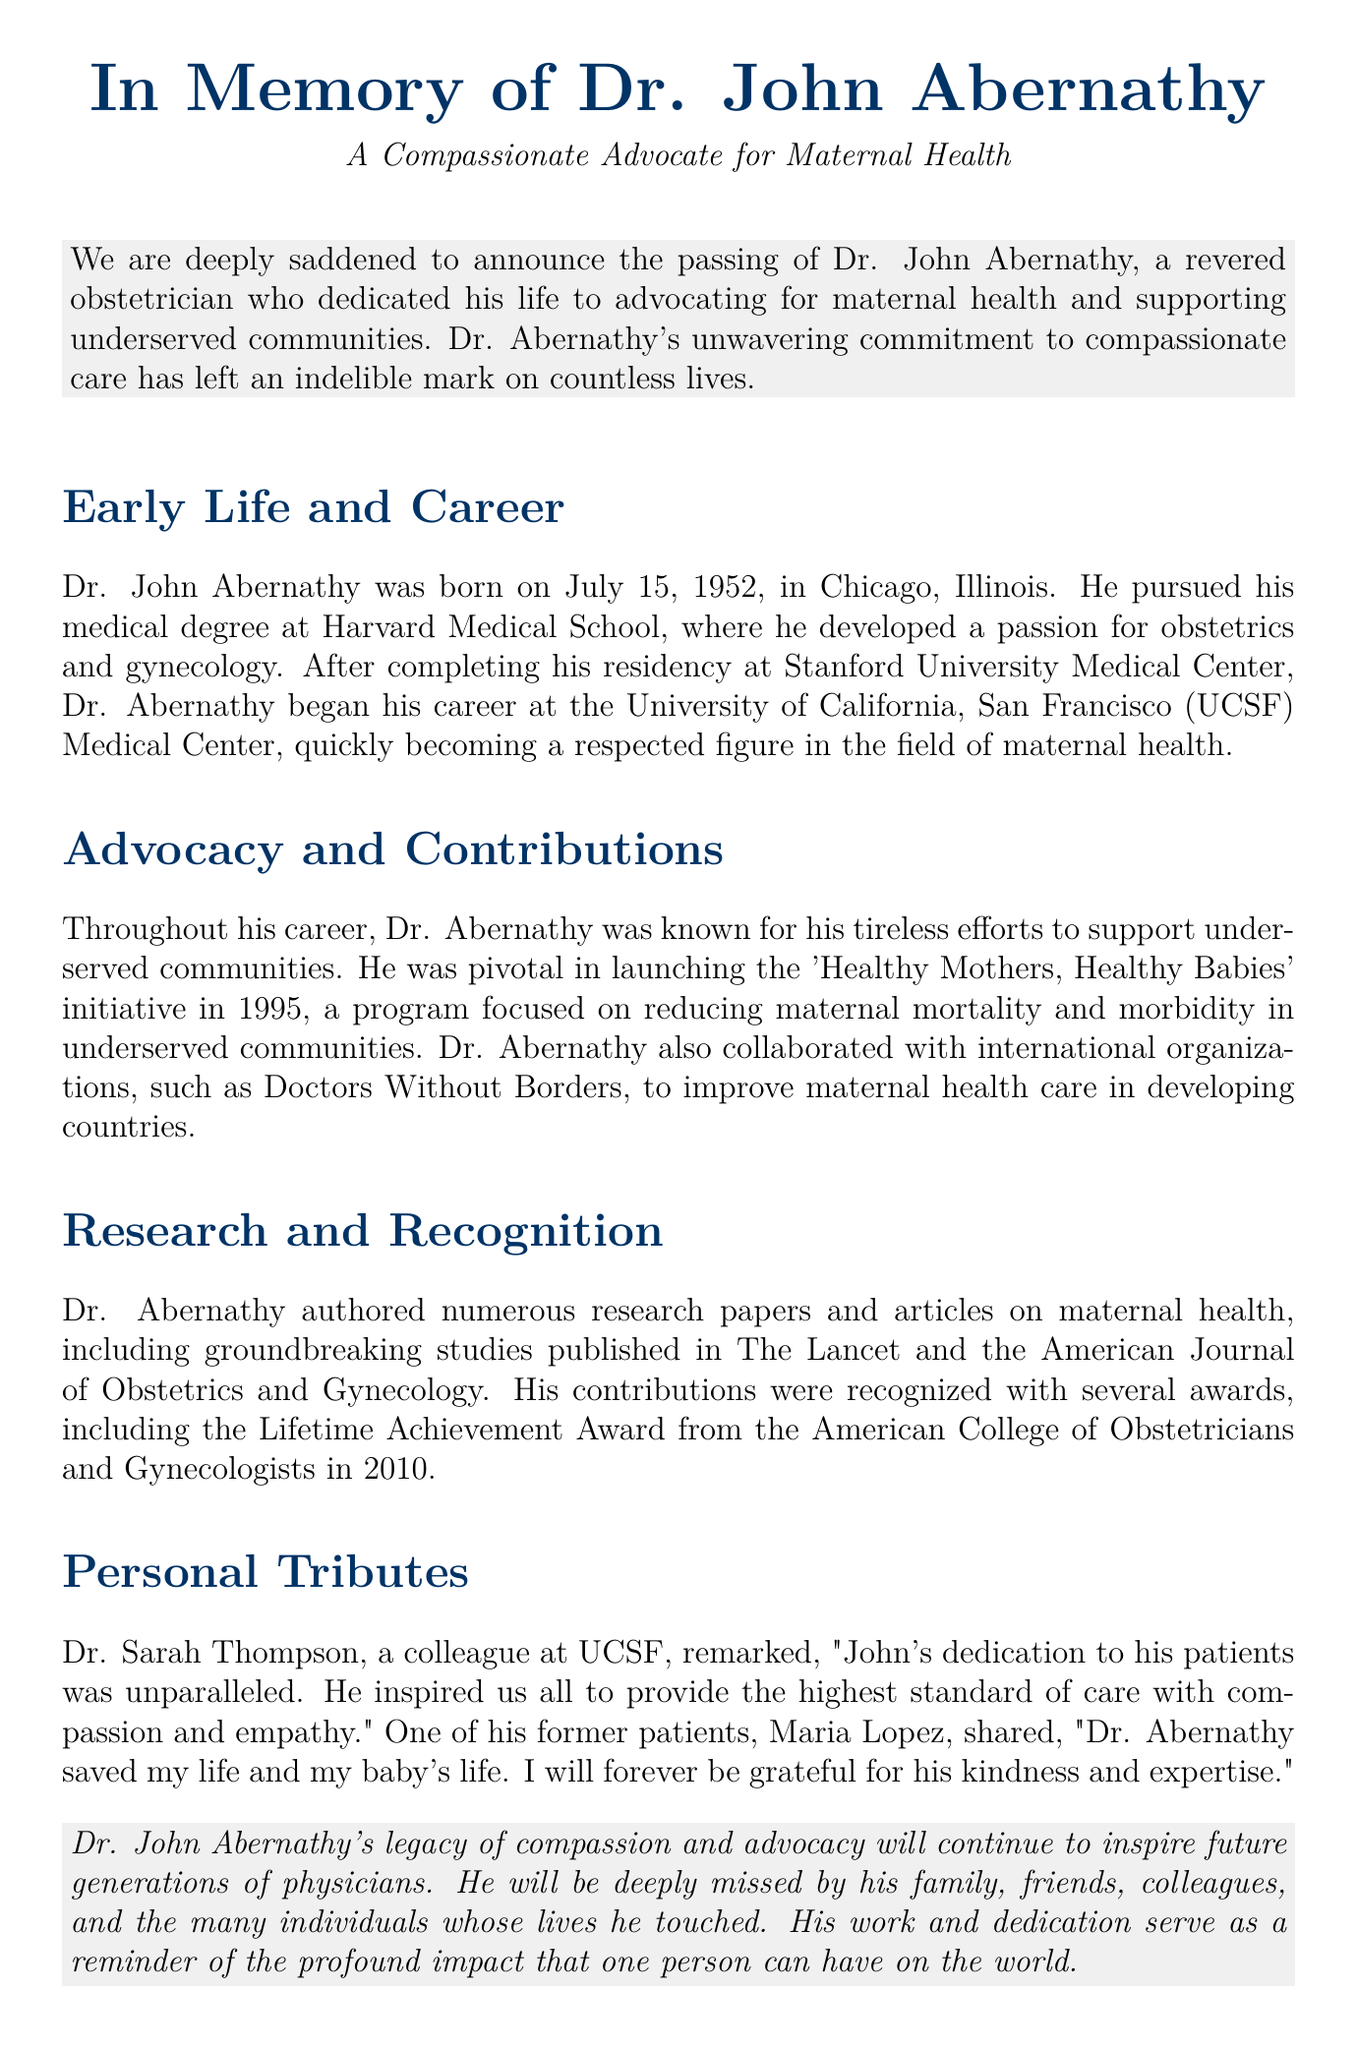What is the full name of the physician? The document mentions the full name of the physician being remembered, which is Dr. John Abernathy.
Answer: Dr. John Abernathy When was Dr. Abernathy born? The document states that Dr. Abernathy was born on July 15, 1952.
Answer: July 15, 1952 Which initiative did Dr. Abernathy launch in 1995? The document highlights the 'Healthy Mothers, Healthy Babies' initiative launched by Dr. Abernathy in 1995.
Answer: Healthy Mothers, Healthy Babies What award did Dr. Abernathy receive in 2010? According to the document, Dr. Abernathy received the Lifetime Achievement Award from the American College of Obstetricians and Gynecologists in 2010.
Answer: Lifetime Achievement Award What was Dr. Sarah Thompson's relationship to Dr. Abernathy? The document indicates that Dr. Sarah Thompson was a colleague of Dr. Abernathy at UCSF.
Answer: Colleague What city was Dr. Abernathy born in? The document states that Dr. Abernathy was born in Chicago, Illinois.
Answer: Chicago Which countries did Dr. Abernathy collaborate with international organizations to support? The document mentions that Dr. Abernathy collaborated with organizations like Doctors Without Borders to improve maternal health care in developing countries.
Answer: Developing countries What type of care was Dr. Abernathy known for advocating? The document notes that Dr. Abernathy was known for advocating for maternal health care.
Answer: Maternal health care 